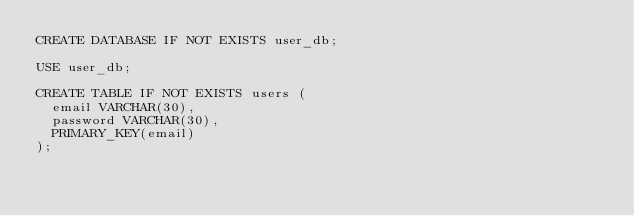Convert code to text. <code><loc_0><loc_0><loc_500><loc_500><_SQL_>CREATE DATABASE IF NOT EXISTS user_db;

USE user_db;

CREATE TABLE IF NOT EXISTS users (
  email VARCHAR(30),
  password VARCHAR(30),
  PRIMARY_KEY(email)
);
</code> 